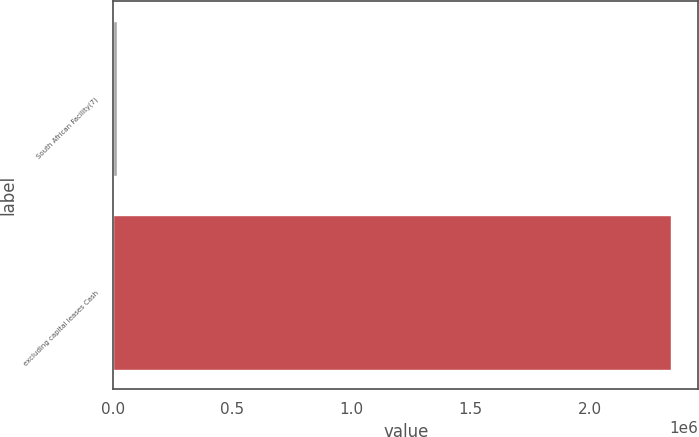<chart> <loc_0><loc_0><loc_500><loc_500><bar_chart><fcel>South African Facility(7)<fcel>excluding capital leases Cash<nl><fcel>17722<fcel>2.33894e+06<nl></chart> 